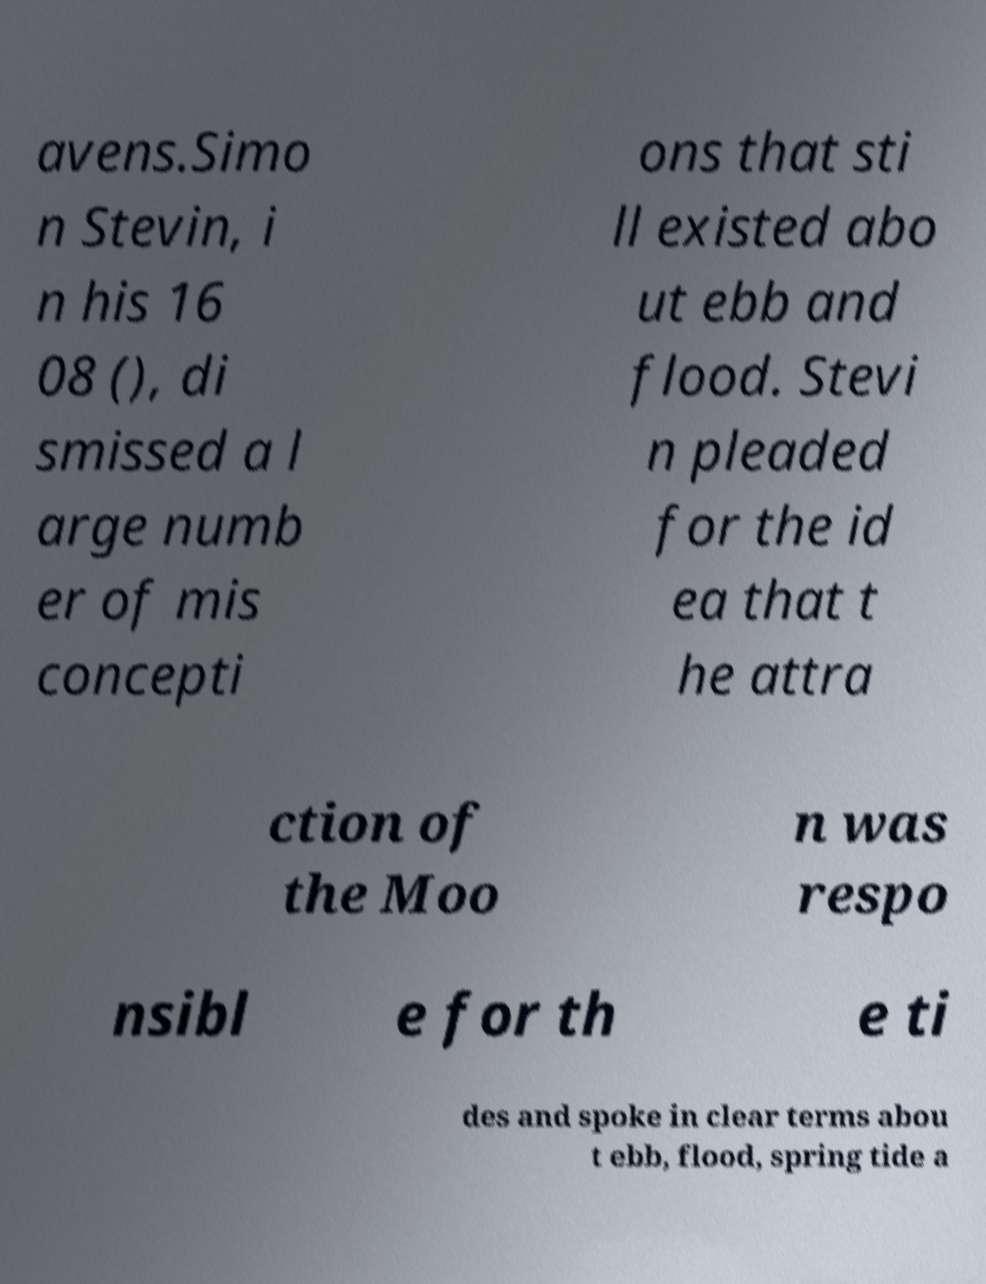Could you extract and type out the text from this image? avens.Simo n Stevin, i n his 16 08 (), di smissed a l arge numb er of mis concepti ons that sti ll existed abo ut ebb and flood. Stevi n pleaded for the id ea that t he attra ction of the Moo n was respo nsibl e for th e ti des and spoke in clear terms abou t ebb, flood, spring tide a 